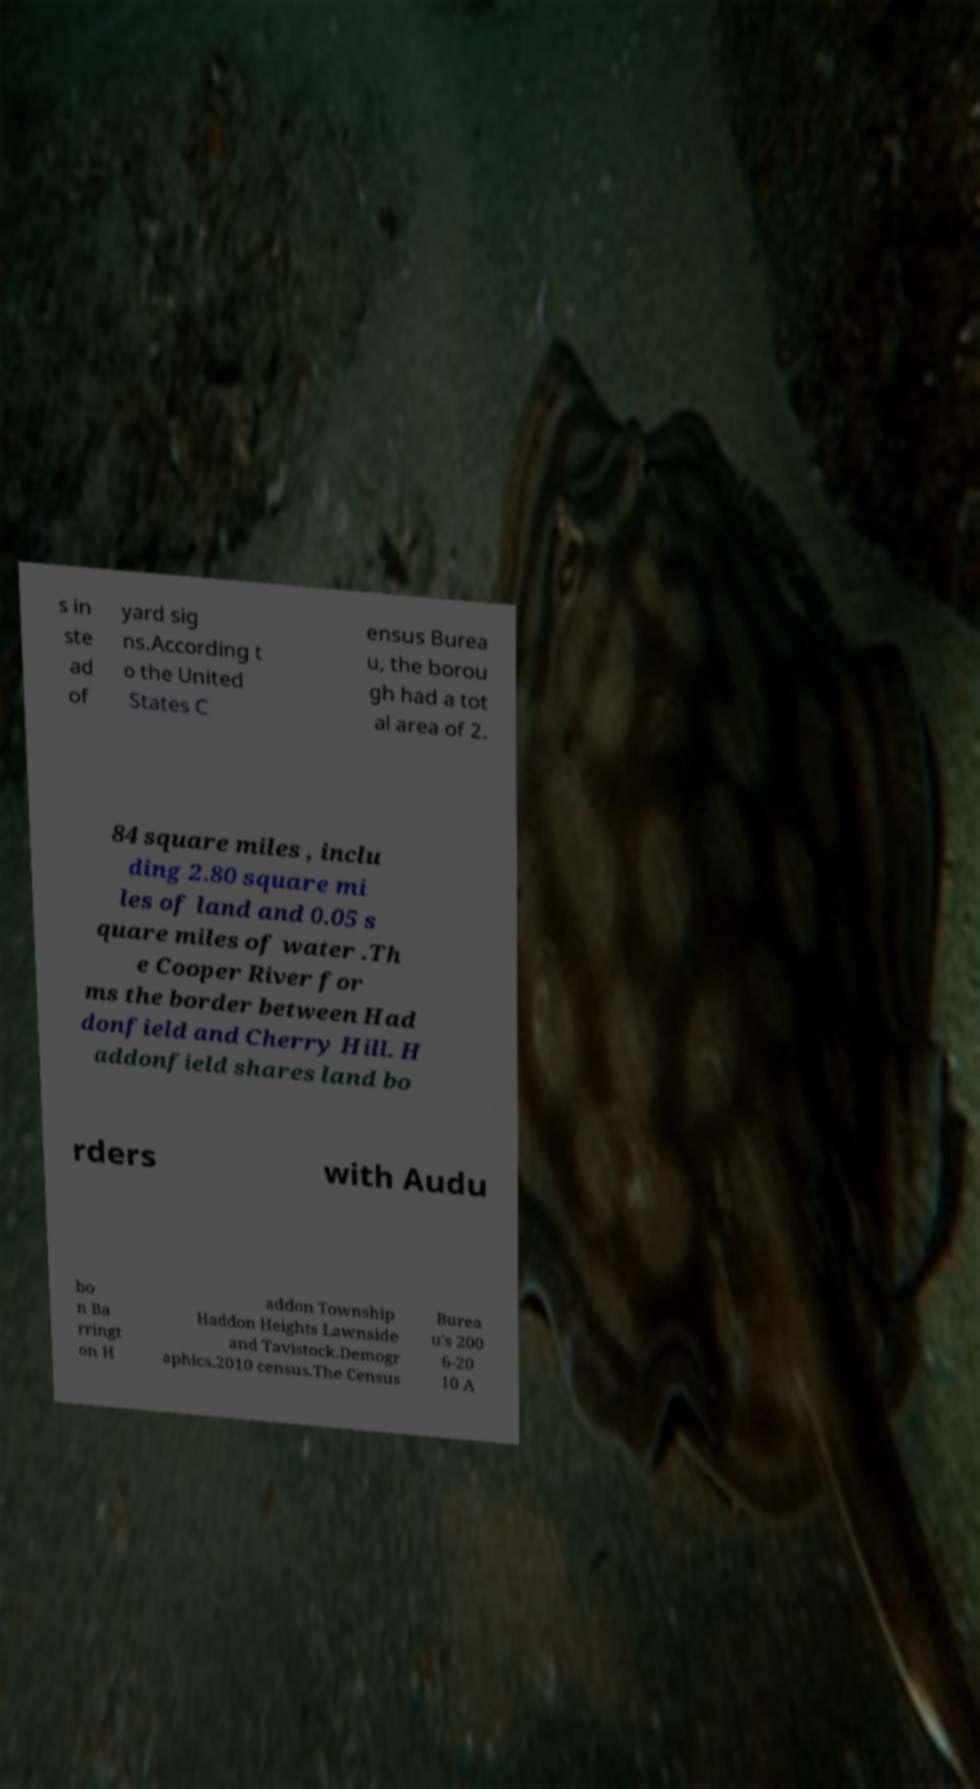Could you assist in decoding the text presented in this image and type it out clearly? s in ste ad of yard sig ns.According t o the United States C ensus Burea u, the borou gh had a tot al area of 2. 84 square miles , inclu ding 2.80 square mi les of land and 0.05 s quare miles of water .Th e Cooper River for ms the border between Had donfield and Cherry Hill. H addonfield shares land bo rders with Audu bo n Ba rringt on H addon Township Haddon Heights Lawnside and Tavistock.Demogr aphics.2010 census.The Census Burea u's 200 6-20 10 A 